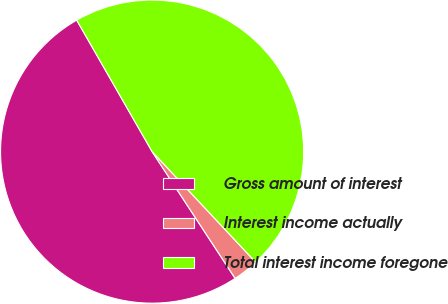Convert chart to OTSL. <chart><loc_0><loc_0><loc_500><loc_500><pie_chart><fcel>Gross amount of interest<fcel>Interest income actually<fcel>Total interest income foregone<nl><fcel>50.94%<fcel>2.75%<fcel>46.31%<nl></chart> 